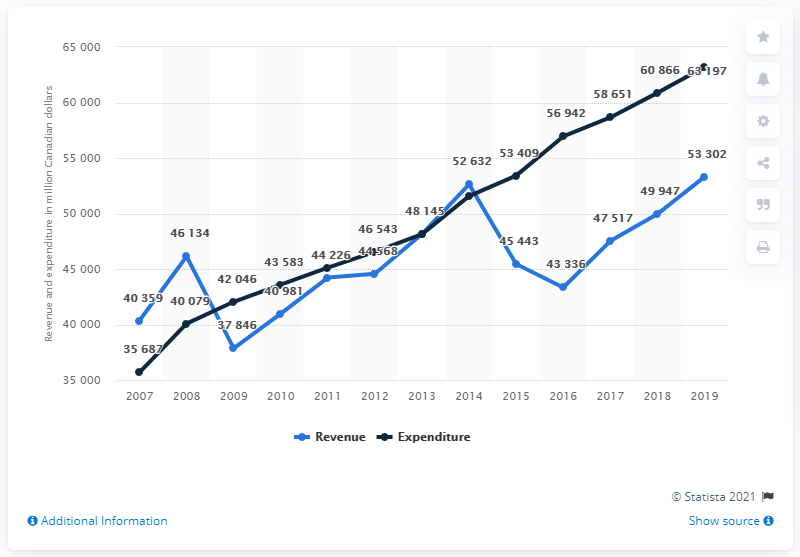List a handful of essential elements in this visual. In 2019, Alberta's revenue was approximately 53,302 million dollars. 